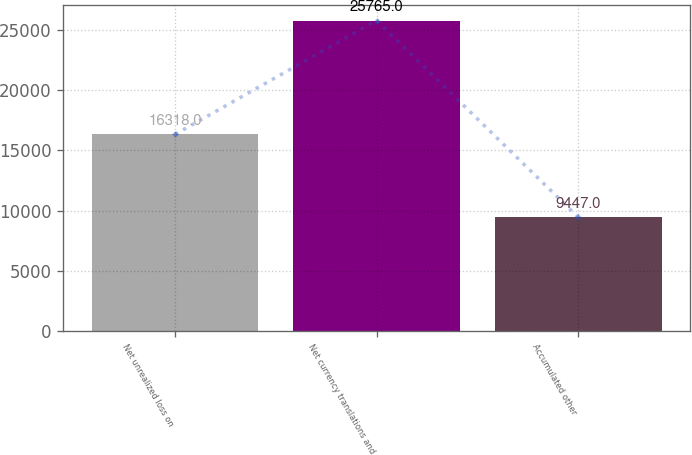<chart> <loc_0><loc_0><loc_500><loc_500><bar_chart><fcel>Net unrealized loss on<fcel>Net currency translations and<fcel>Accumulated other<nl><fcel>16318<fcel>25765<fcel>9447<nl></chart> 